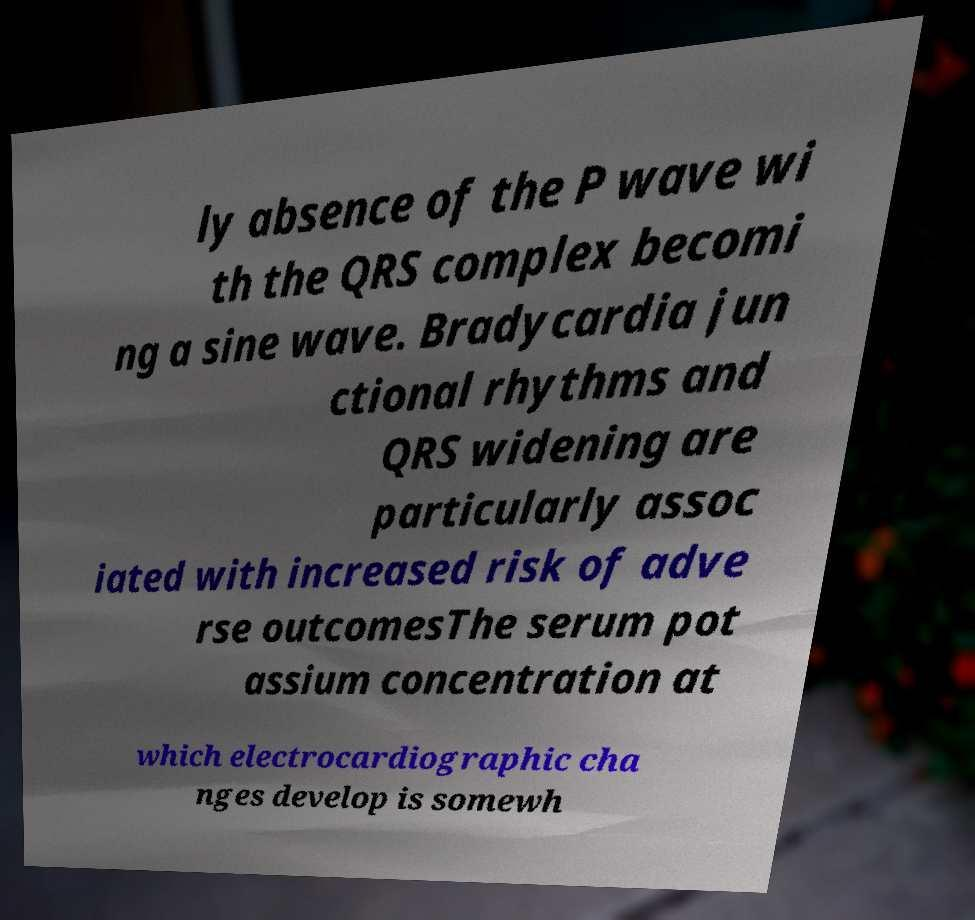Can you read and provide the text displayed in the image?This photo seems to have some interesting text. Can you extract and type it out for me? ly absence of the P wave wi th the QRS complex becomi ng a sine wave. Bradycardia jun ctional rhythms and QRS widening are particularly assoc iated with increased risk of adve rse outcomesThe serum pot assium concentration at which electrocardiographic cha nges develop is somewh 